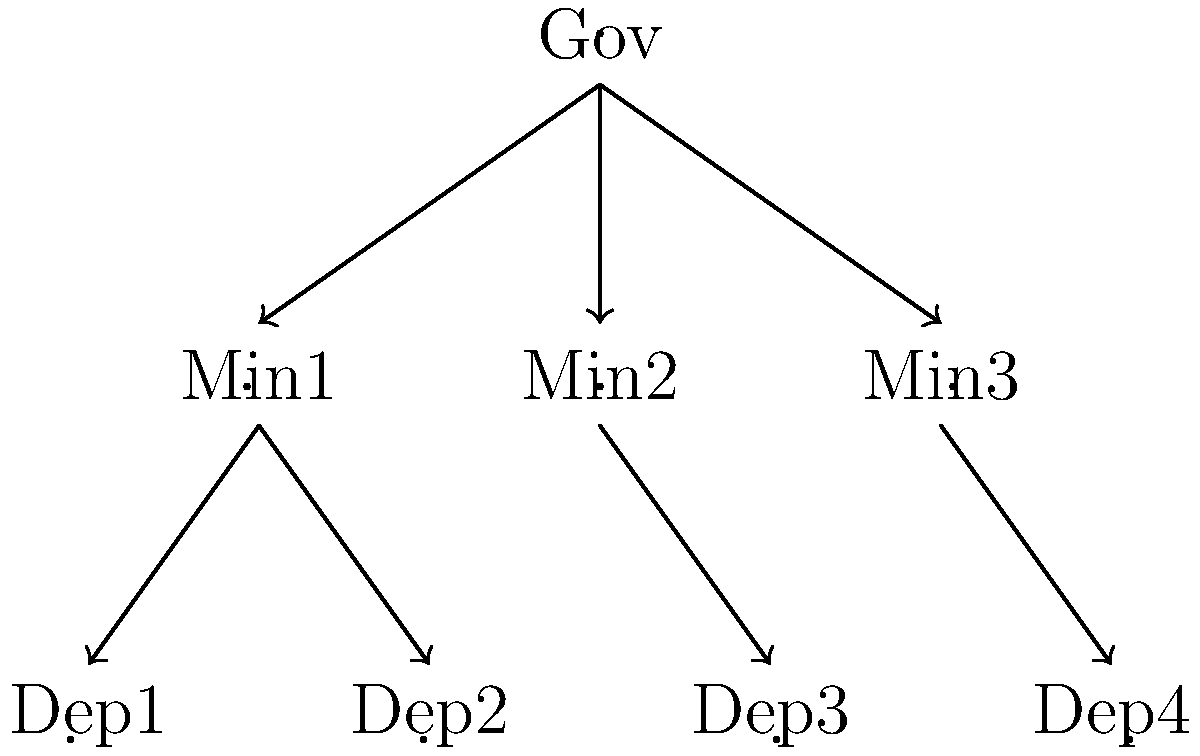In the organizational hierarchy of an Eastern European government shown above, which subgroup structure best represents the relationship between ministries and their departments? To answer this question, we need to analyze the organizational structure presented in the diagram:

1. The top-level node "Gov" represents the central government.

2. Below the central government, we see three nodes labeled "Min1", "Min2", and "Min3", which represent different ministries.

3. Under these ministries, we observe four nodes labeled "Dep1", "Dep2", "Dep3", and "Dep4", representing various departments.

4. The arrows indicate a hierarchical relationship, showing that departments are subordinate to ministries.

5. In group theory terms, this structure resembles a normal subgroup relationship, where:
   - The entire government is the main group G.
   - The set of all ministries forms a normal subgroup H of G.
   - The set of all departments forms a normal subgroup K of H.

6. This creates a chain of normal subgroups: $K \triangleleft H \triangleleft G$

7. In group theory, this structure is known as a subnormal series or a composition series, depending on whether the subgroups are maximal or not.

Given the Eastern European context and the hierarchical nature of government structures, this subnormal series accurately represents the relationship between ministries and their departments.
Answer: Subnormal series 